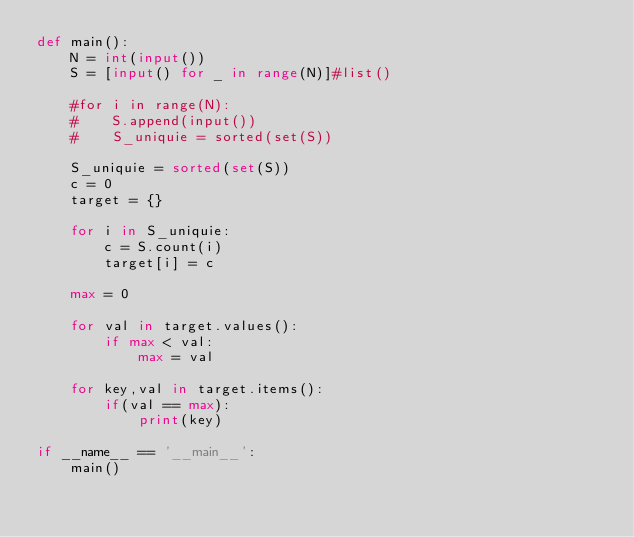Convert code to text. <code><loc_0><loc_0><loc_500><loc_500><_Python_>def main():
    N = int(input())
    S = [input() for _ in range(N)]#list()

    #for i in range(N):
    #    S.append(input())
    #    S_uniquie = sorted(set(S))

    S_uniquie = sorted(set(S))
    c = 0
    target = {}

    for i in S_uniquie:
        c = S.count(i)
        target[i] = c

    max = 0

    for val in target.values():
        if max < val:
            max = val

    for key,val in target.items():
        if(val == max):
            print(key)

if __name__ == '__main__':
    main()</code> 